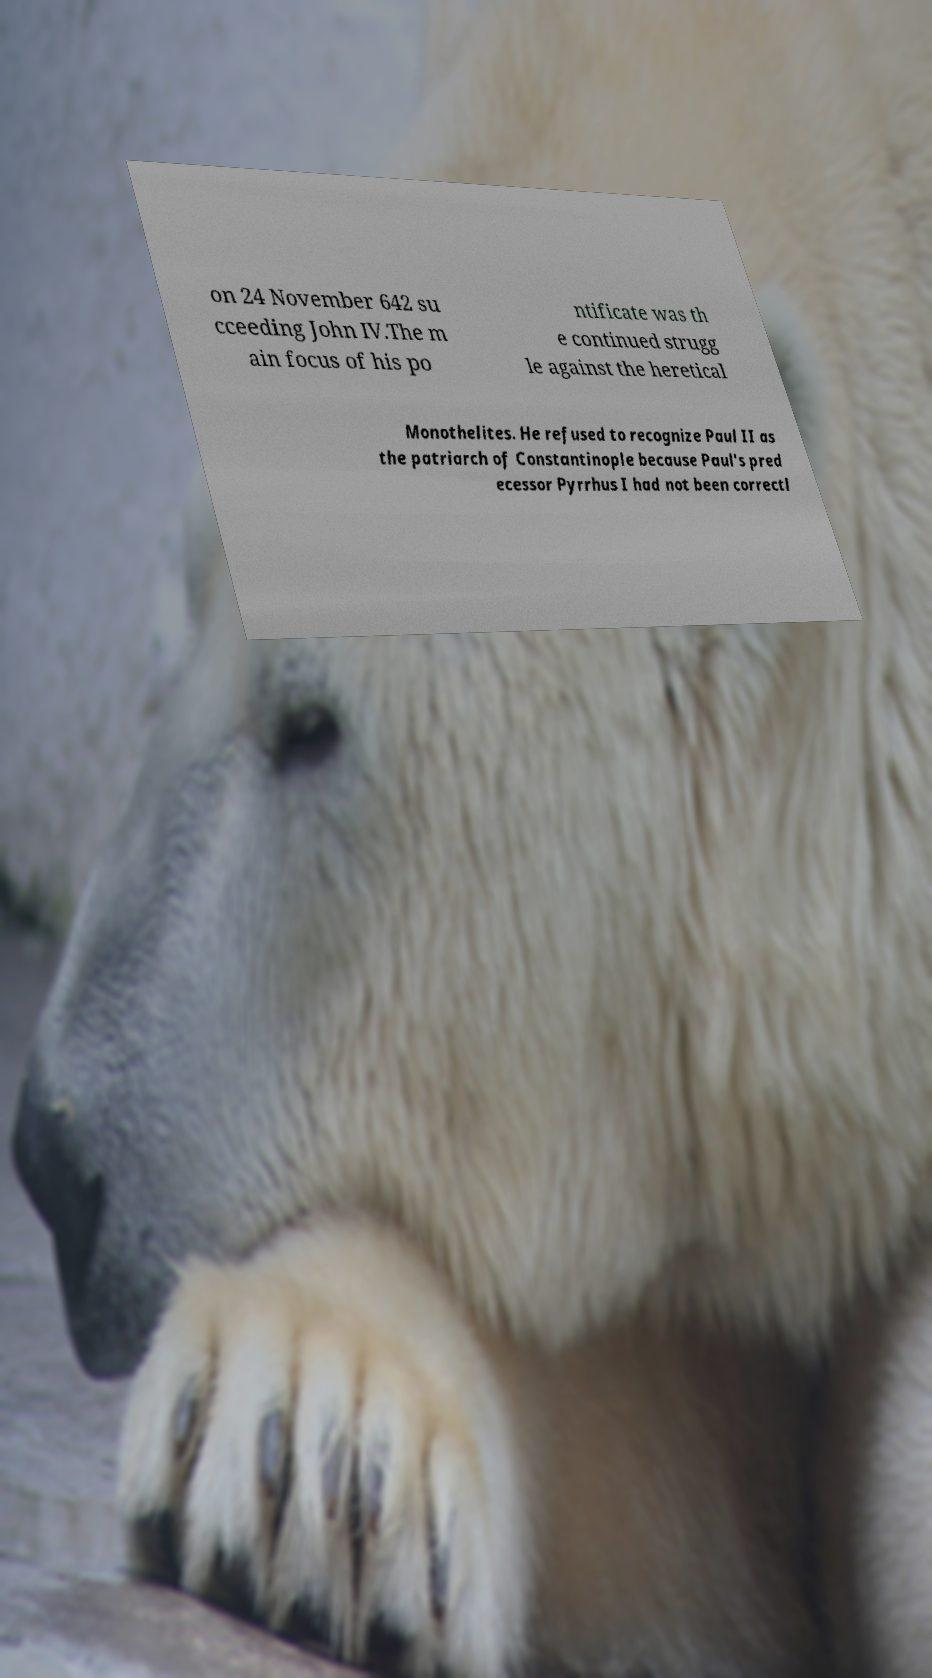Can you accurately transcribe the text from the provided image for me? on 24 November 642 su cceeding John IV.The m ain focus of his po ntificate was th e continued strugg le against the heretical Monothelites. He refused to recognize Paul II as the patriarch of Constantinople because Paul's pred ecessor Pyrrhus I had not been correctl 